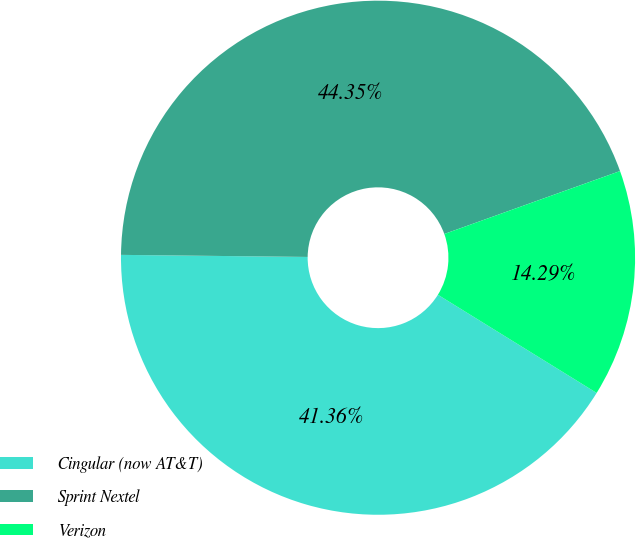Convert chart to OTSL. <chart><loc_0><loc_0><loc_500><loc_500><pie_chart><fcel>Cingular (now AT&T)<fcel>Sprint Nextel<fcel>Verizon<nl><fcel>41.36%<fcel>44.35%<fcel>14.29%<nl></chart> 